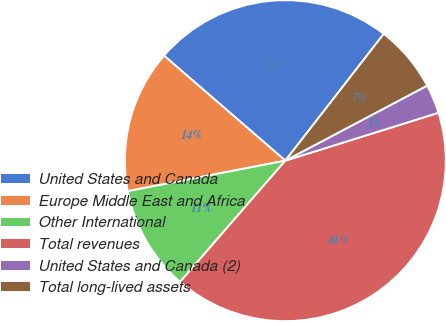Convert chart. <chart><loc_0><loc_0><loc_500><loc_500><pie_chart><fcel>United States and Canada<fcel>Europe Middle East and Africa<fcel>Other International<fcel>Total revenues<fcel>United States and Canada (2)<fcel>Total long-lived assets<nl><fcel>24.15%<fcel>14.4%<fcel>10.58%<fcel>41.2%<fcel>2.92%<fcel>6.75%<nl></chart> 